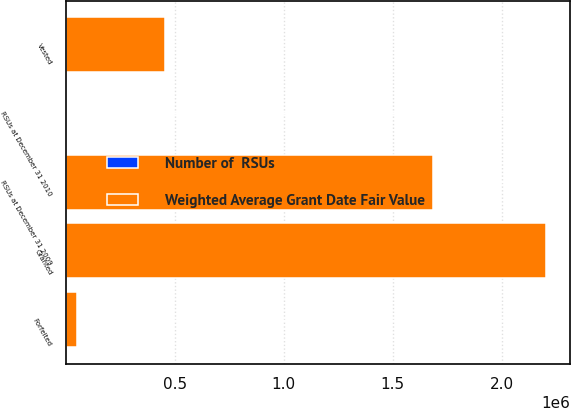<chart> <loc_0><loc_0><loc_500><loc_500><stacked_bar_chart><ecel><fcel>RSUs at December 31 2009<fcel>Granted<fcel>Vested<fcel>Forfeited<fcel>RSUs at December 31 2010<nl><fcel>Weighted Average Grant Date Fair Value<fcel>1.68361e+06<fcel>2.20306e+06<fcel>455765<fcel>52065<fcel>13.75<nl><fcel>Number of  RSUs<fcel>12.23<fcel>10.86<fcel>13.75<fcel>10.99<fcel>11.15<nl></chart> 